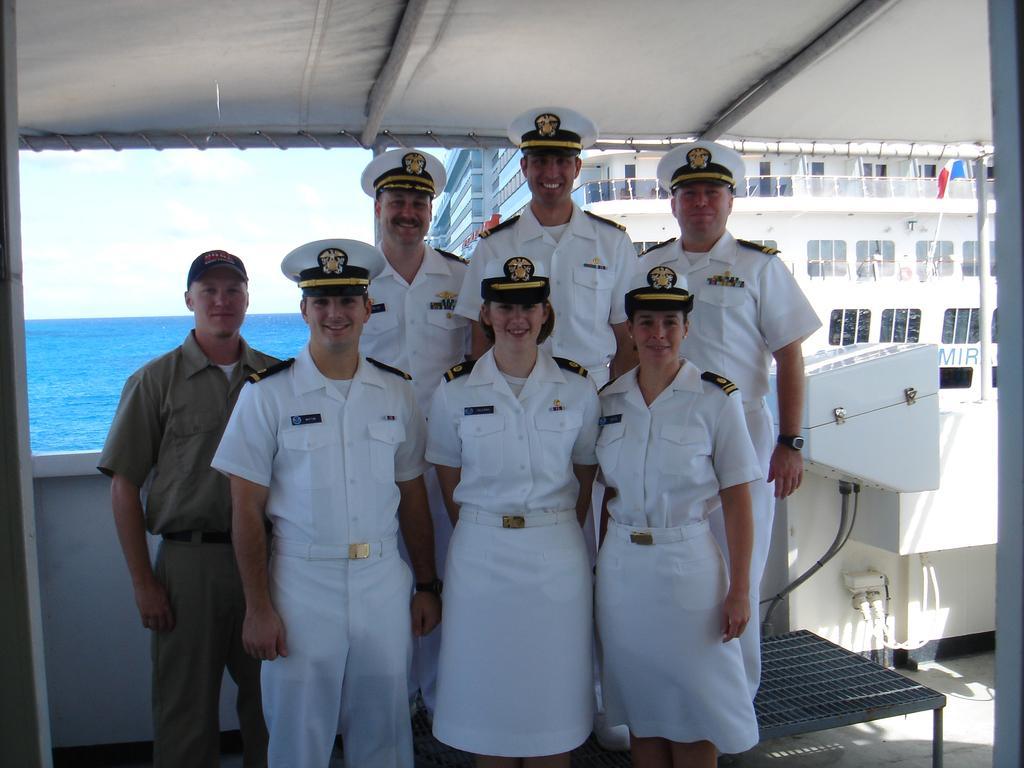Please provide a concise description of this image. In this image, I can see a group of people standing and smiling. On the right side of the image, there is an object. In the background, I can see a flag and ship. There is water and the sky. 